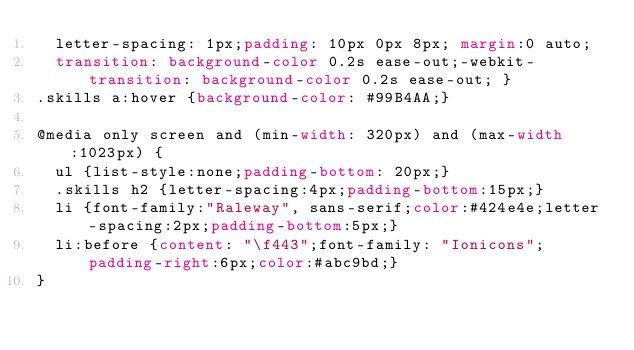Convert code to text. <code><loc_0><loc_0><loc_500><loc_500><_CSS_>  letter-spacing: 1px;padding: 10px 0px 8px; margin:0 auto;
  transition: background-color 0.2s ease-out;-webkit-transition: background-color 0.2s ease-out; }
.skills a:hover {background-color: #99B4AA;}

@media only screen and (min-width: 320px) and (max-width:1023px) {
  ul {list-style:none;padding-bottom: 20px;}
  .skills h2 {letter-spacing:4px;padding-bottom:15px;}
  li {font-family:"Raleway", sans-serif;color:#424e4e;letter-spacing:2px;padding-bottom:5px;}
  li:before {content: "\f443";font-family: "Ionicons";padding-right:6px;color:#abc9bd;}
}</code> 